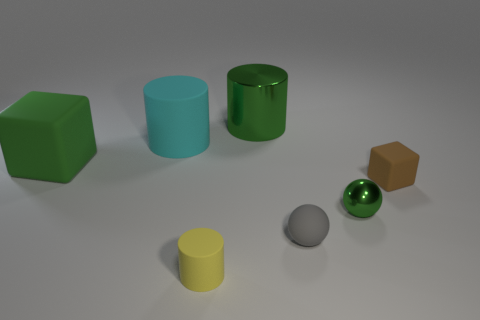What color is the small rubber object that is the same shape as the big cyan thing?
Offer a very short reply. Yellow. There is a sphere to the left of the small green metal ball; what material is it?
Ensure brevity in your answer.  Rubber. There is a yellow rubber object that is the same shape as the large cyan matte thing; what is its size?
Offer a terse response. Small. What number of green spheres have the same material as the tiny brown thing?
Make the answer very short. 0. What number of big objects have the same color as the large block?
Provide a succinct answer. 1. How many things are either cylinders that are to the right of the small yellow matte cylinder or rubber things that are to the right of the gray object?
Give a very brief answer. 2. Are there fewer yellow matte objects that are behind the yellow matte object than tiny blue objects?
Ensure brevity in your answer.  No. Are there any cyan matte spheres that have the same size as the gray rubber ball?
Offer a terse response. No. What is the color of the big metallic cylinder?
Offer a terse response. Green. Is the size of the cyan rubber cylinder the same as the green cube?
Offer a terse response. Yes. 